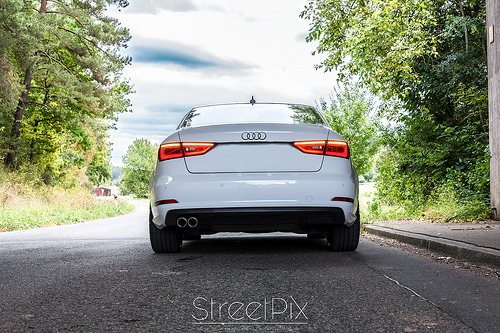<image>
Is the road under the car? Yes. The road is positioned underneath the car, with the car above it in the vertical space. 